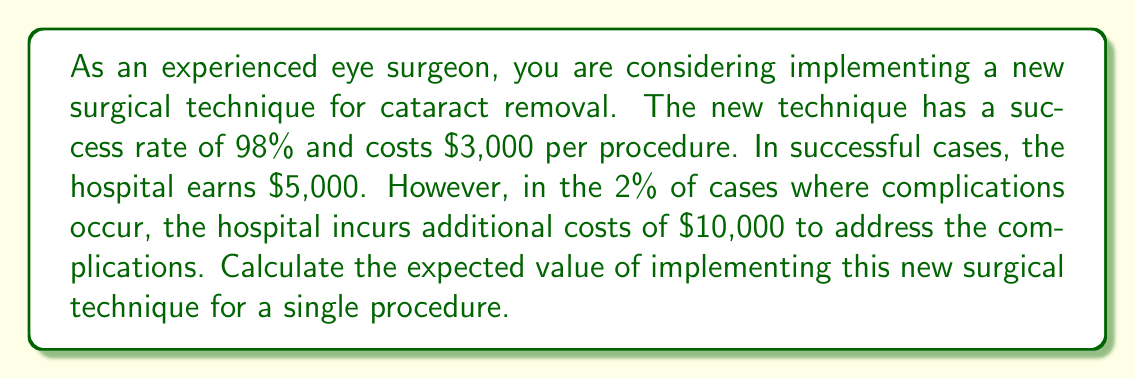Provide a solution to this math problem. To calculate the expected value, we need to consider both the successful outcomes and the potential complications:

1. Successful outcome probability: 98% = 0.98
2. Complication probability: 2% = 0.02

Let's calculate the expected value for each scenario:

1. Successful outcome:
   - Probability: 0.98
   - Revenue: $5,000
   - Cost: $3,000
   - Profit: $5,000 - $3,000 = $2,000
   Expected value of success: $0.98 \times 2,000 = $1,960

2. Complication scenario:
   - Probability: 0.02
   - Revenue: $5,000
   - Cost: $3,000 + $10,000 = $13,000
   - Loss: $5,000 - $13,000 = -$8,000
   Expected value of complication: $0.02 \times (-8,000) = -$160

The total expected value is the sum of these two scenarios:

$$ E = (0.98 \times 2,000) + (0.02 \times (-8,000)) = 1,960 - 160 = 1,800 $$

Therefore, the expected value of implementing the new surgical technique for a single procedure is $1,800.
Answer: $1,800 